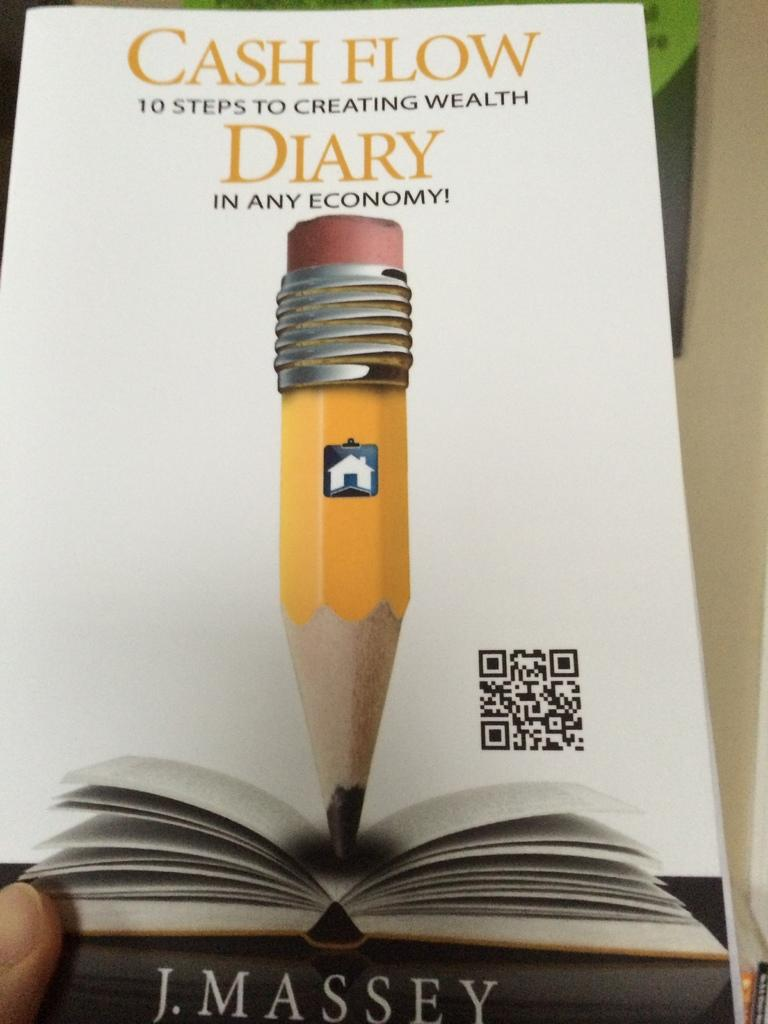<image>
Summarize the visual content of the image. A copy of the book titled cash flow diary by J. Massey. 